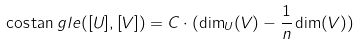<formula> <loc_0><loc_0><loc_500><loc_500>\cos \tan g l e ( [ U ] , [ V ] ) = C \cdot ( \dim _ { U } ( V ) - \frac { 1 } { n } \dim ( V ) )</formula> 